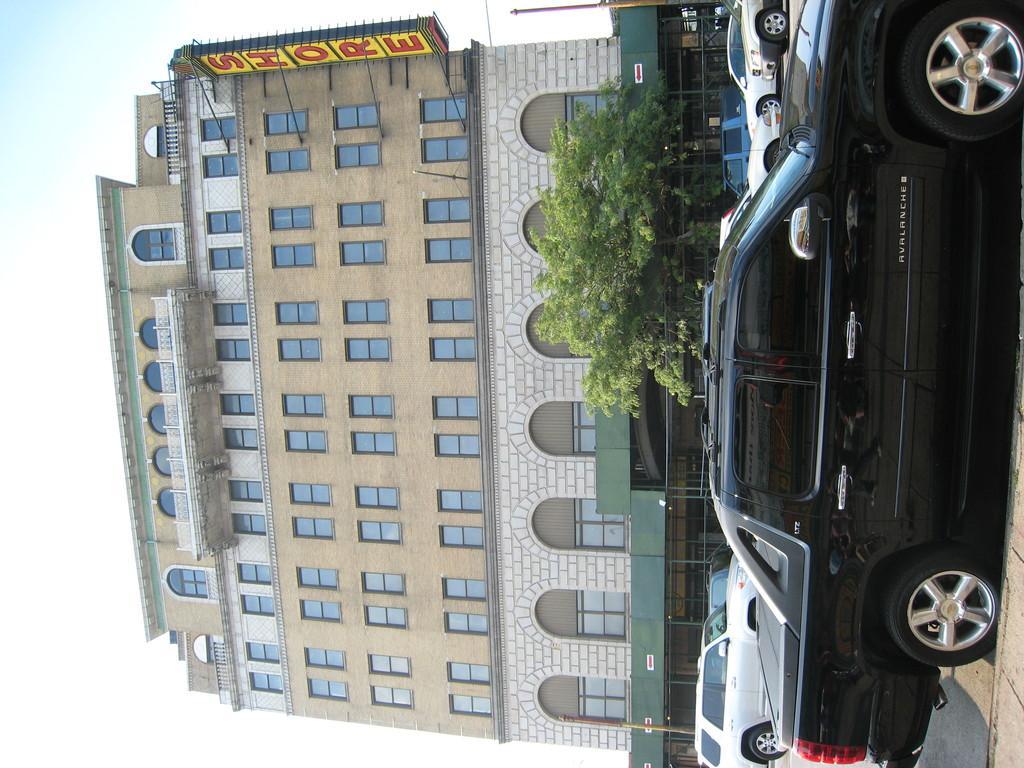Please provide a concise description of this image. This is the building with the windows and the glass doors. Here is a tree. I can see the cars on the road. This is a name board, which is attached to the building. 